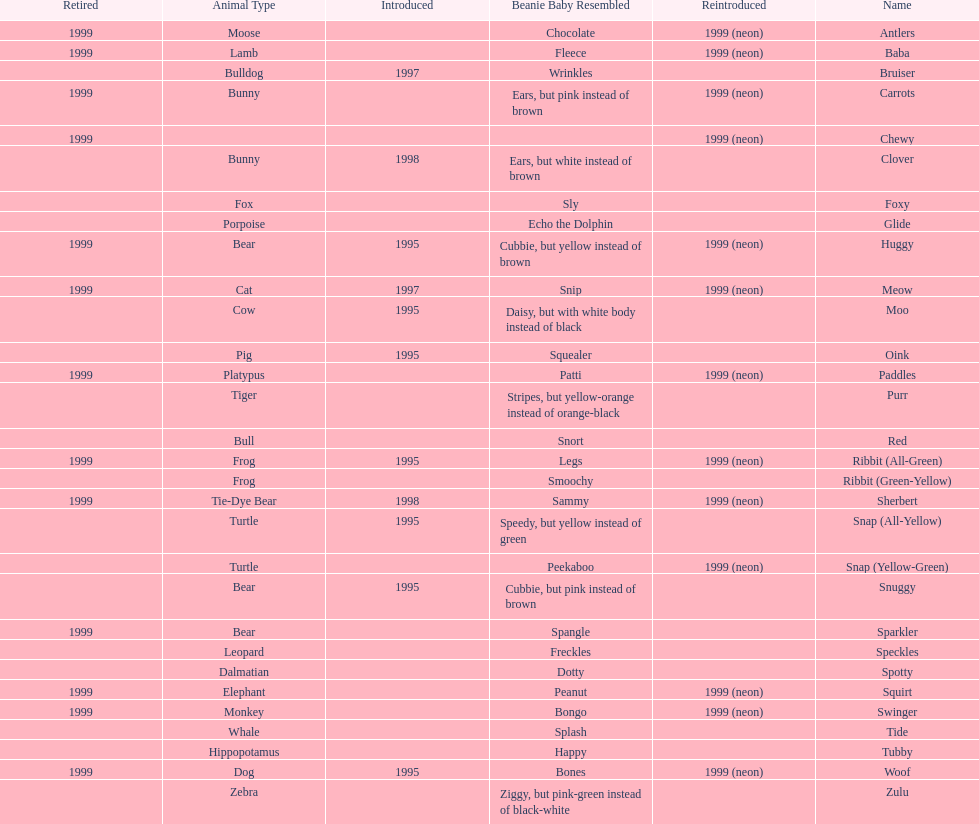What are the names listed? Antlers, Baba, Bruiser, Carrots, Chewy, Clover, Foxy, Glide, Huggy, Meow, Moo, Oink, Paddles, Purr, Red, Ribbit (All-Green), Ribbit (Green-Yellow), Sherbert, Snap (All-Yellow), Snap (Yellow-Green), Snuggy, Sparkler, Speckles, Spotty, Squirt, Swinger, Tide, Tubby, Woof, Zulu. Of these, which is the only pet without an animal type listed? Chewy. 